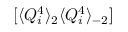Convert formula to latex. <formula><loc_0><loc_0><loc_500><loc_500>[ \langle Q _ { i } ^ { 4 } \rangle _ { 2 } \langle Q _ { i } ^ { 4 } \rangle _ { - 2 } ]</formula> 